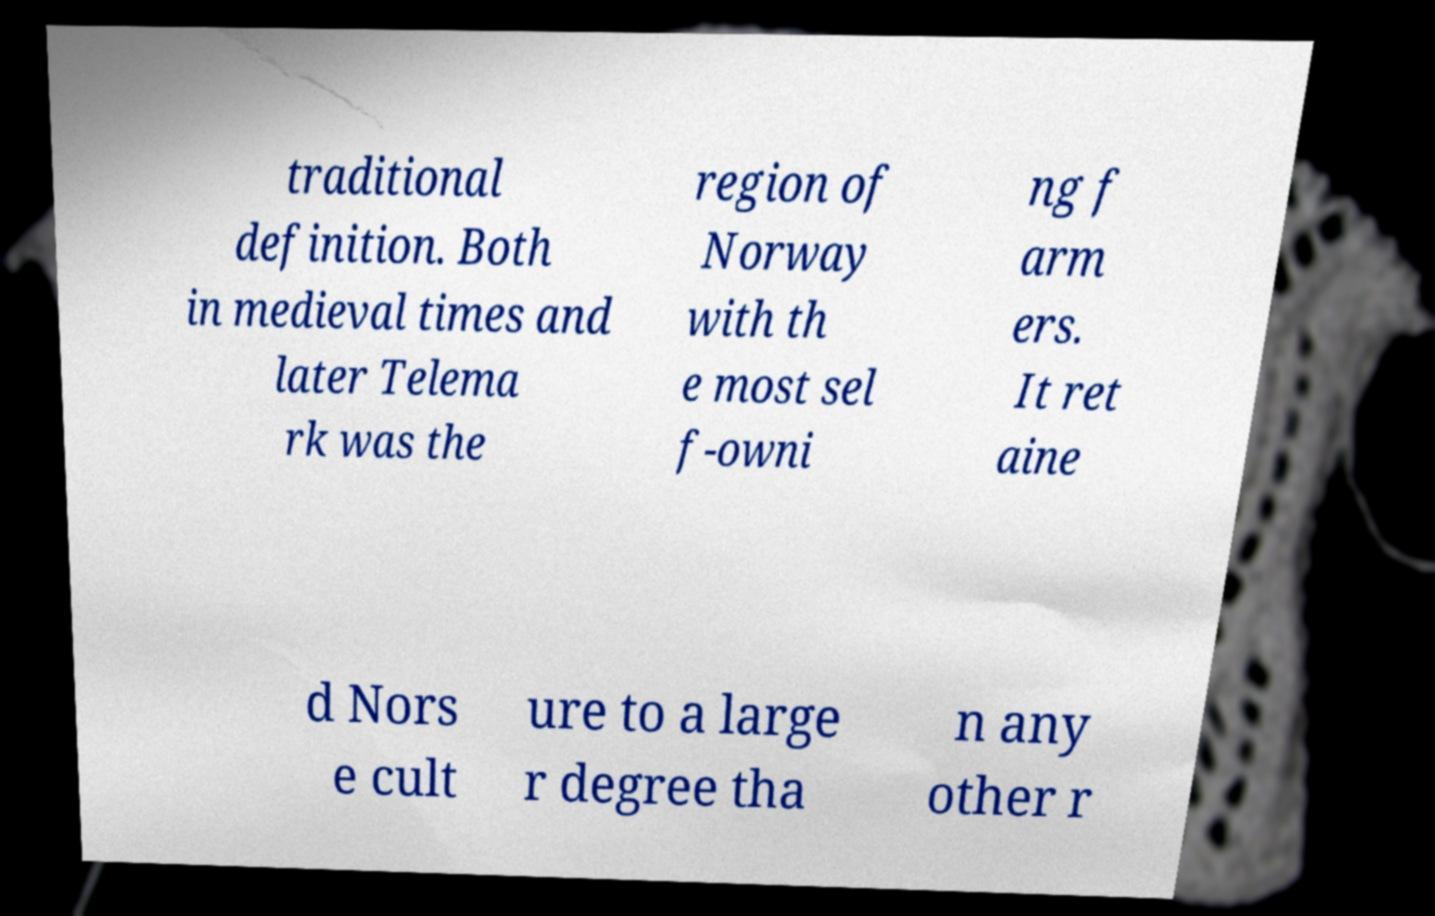Could you assist in decoding the text presented in this image and type it out clearly? traditional definition. Both in medieval times and later Telema rk was the region of Norway with th e most sel f-owni ng f arm ers. It ret aine d Nors e cult ure to a large r degree tha n any other r 